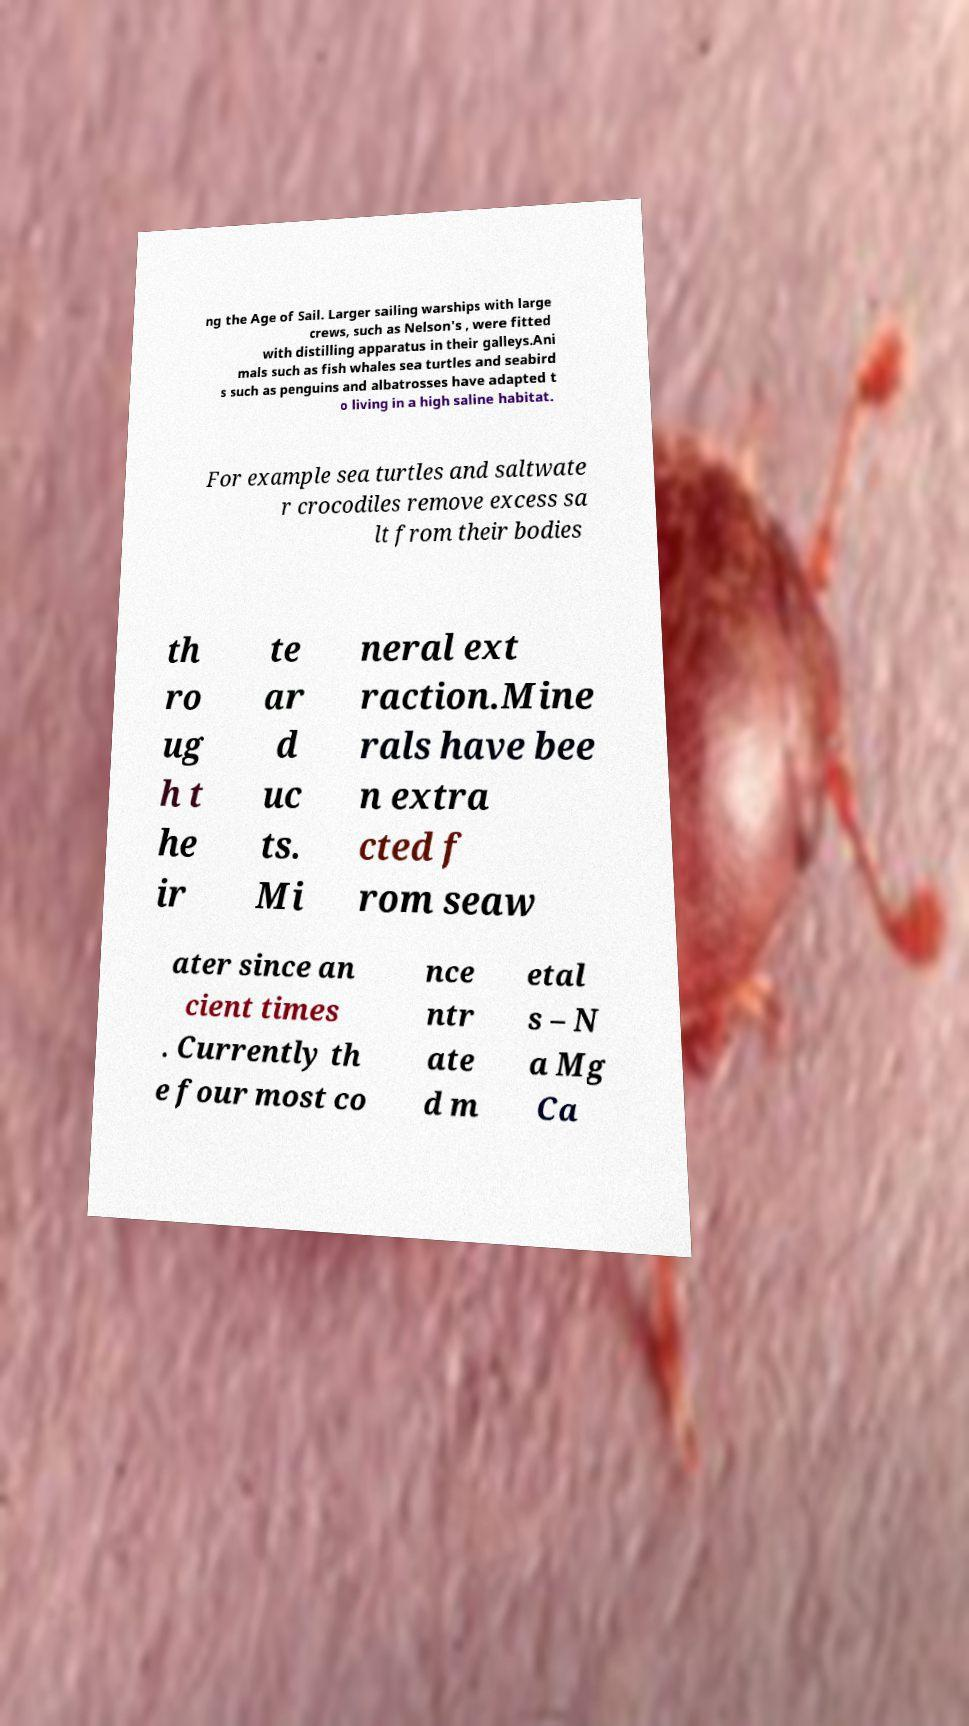There's text embedded in this image that I need extracted. Can you transcribe it verbatim? ng the Age of Sail. Larger sailing warships with large crews, such as Nelson's , were fitted with distilling apparatus in their galleys.Ani mals such as fish whales sea turtles and seabird s such as penguins and albatrosses have adapted t o living in a high saline habitat. For example sea turtles and saltwate r crocodiles remove excess sa lt from their bodies th ro ug h t he ir te ar d uc ts. Mi neral ext raction.Mine rals have bee n extra cted f rom seaw ater since an cient times . Currently th e four most co nce ntr ate d m etal s – N a Mg Ca 